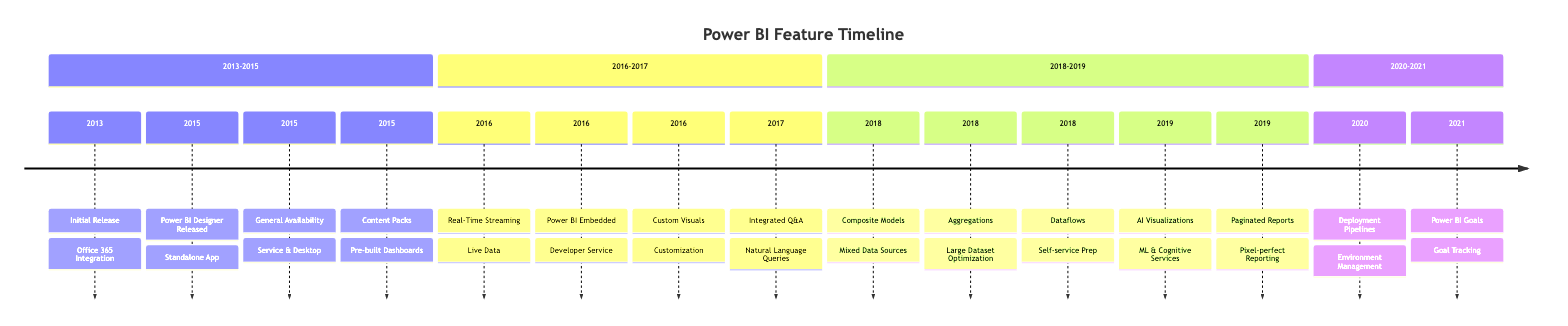What was the year of the Initial Release of Power BI? The year for the Initial Release node in the diagram is specified as 2013. The node provides a clear timeline point for when Power BI was officially launched.
Answer: 2013 What feature was introduced in 2015 in Power BI? The diagram shows several instances of features released in 2015. One of them is "Content Packs," which refers to the introduction of pre-built dashboards and reports for popular services. The year is visible alongside the description in the timeline.
Answer: Content Packs How many features were introduced in 2016? By analyzing the nodes in the diagram for the 2016 section, I can count four features released, namely Real-Time Streaming, Power BI Embedded, Custom Visuals, and Integrated Q&A. Each feature is represented as a separate entry under the 2016 category on the timeline.
Answer: 4 What is the primary focus of the 2018 updates? In 2018, there were three key updates related to data handling: Composite Models, Aggregations, and Dataflows, indicating a strong emphasis on improving how data sources are managed and optimized. Each update is listed and contributes to the overall functionality enhancement regarding data management in Power BI.
Answer: Data handling What feature came after the Power BI Goals? The diagram indicates that the next feature addition after Power BI Goals in 2021 is absent, as there are no further updates mentioned for that timeline frame. The lack of data points indicates the culmination of the updates in the listed categories.
Answer: None Which new functionality was aimed towards developers? The functionality explicitly designed for developers is Power BI Embedded, which is highlighted along with its introduction date in 2016. This describes an embedded analytics service tailored for developers directly within the timeline.
Answer: Power BI Embedded Do any updates from 2019 focus on Artificial Intelligence? The node detailing AI Visualizations in 2019 confirms a focus on Artificial Intelligence, specifically mentioning features such as Auto ML and cognitive services. This is directly indicated in the timeline segment for that year.
Answer: Yes How does Composite Models enhance BI capability? Composite Models allow for the combination of direct query and import data sources within the same model, which enhances BI capabilities by enabling users to work with diverse data sources more effectively. The description under the 2018 node outlines this functionality clearly.
Answer: Mixed Data Sources What major change was introduced with Deployment Pipelines? The Deployment Pipelines feature introduced in 2020 brought about Pipeline management for deploying BI content across different environments. This enhancement simplifies the management of BI deployment processes, as noted in the 2020 section of the diagram.
Answer: Environment Management 